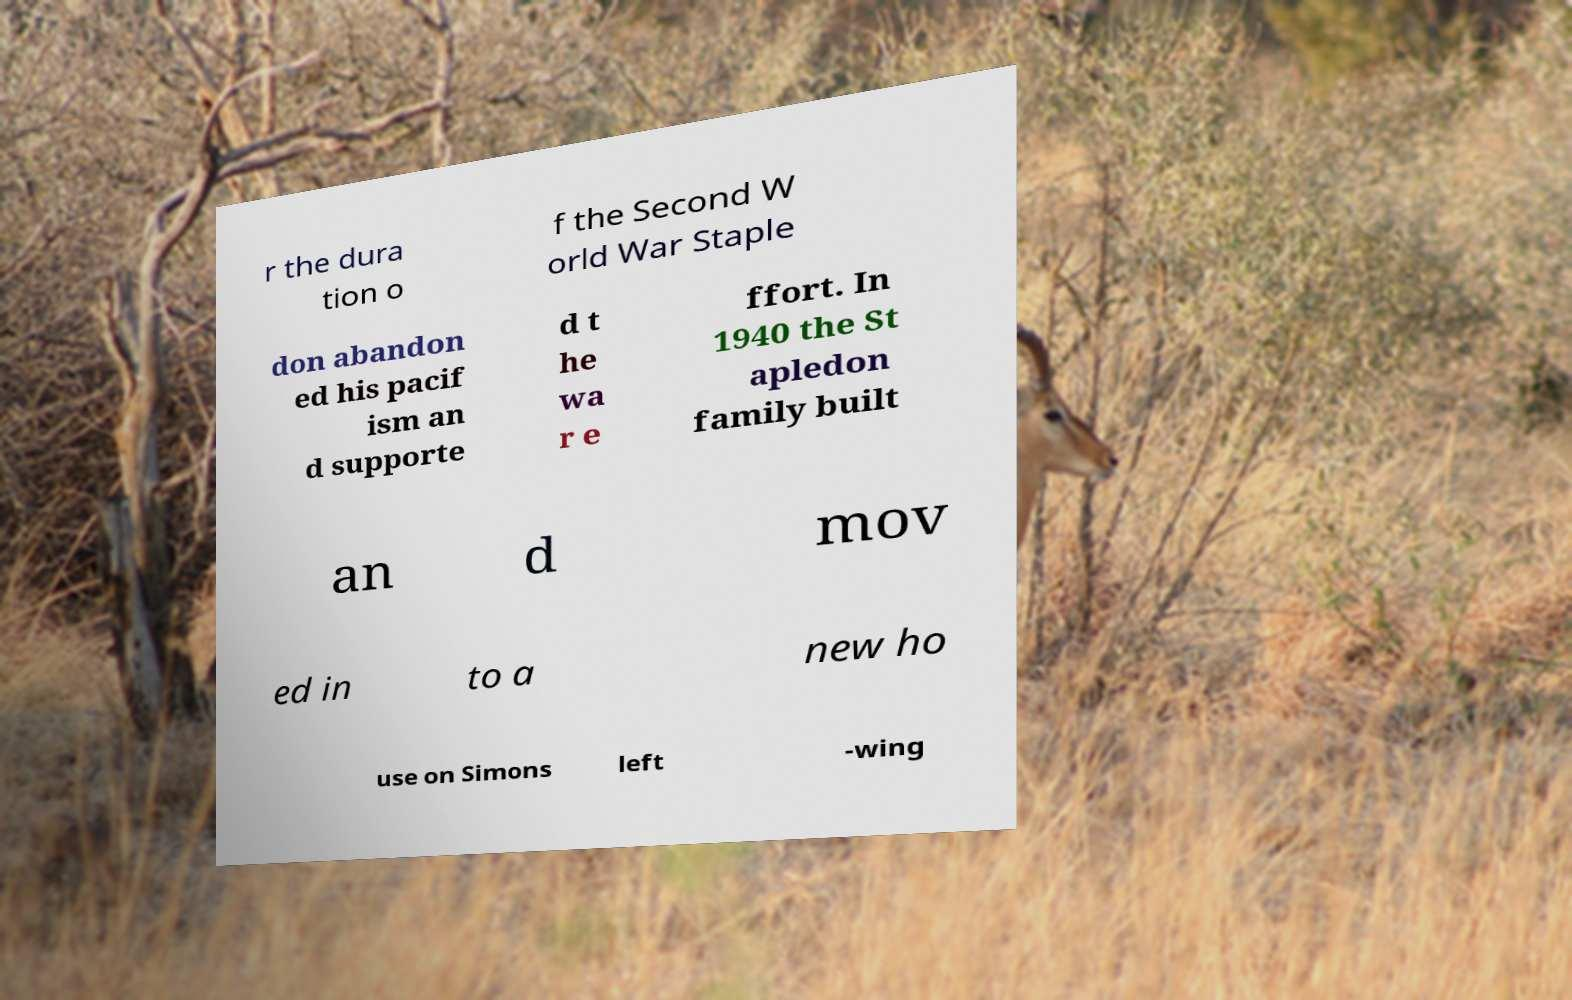Can you read and provide the text displayed in the image?This photo seems to have some interesting text. Can you extract and type it out for me? r the dura tion o f the Second W orld War Staple don abandon ed his pacif ism an d supporte d t he wa r e ffort. In 1940 the St apledon family built an d mov ed in to a new ho use on Simons left -wing 